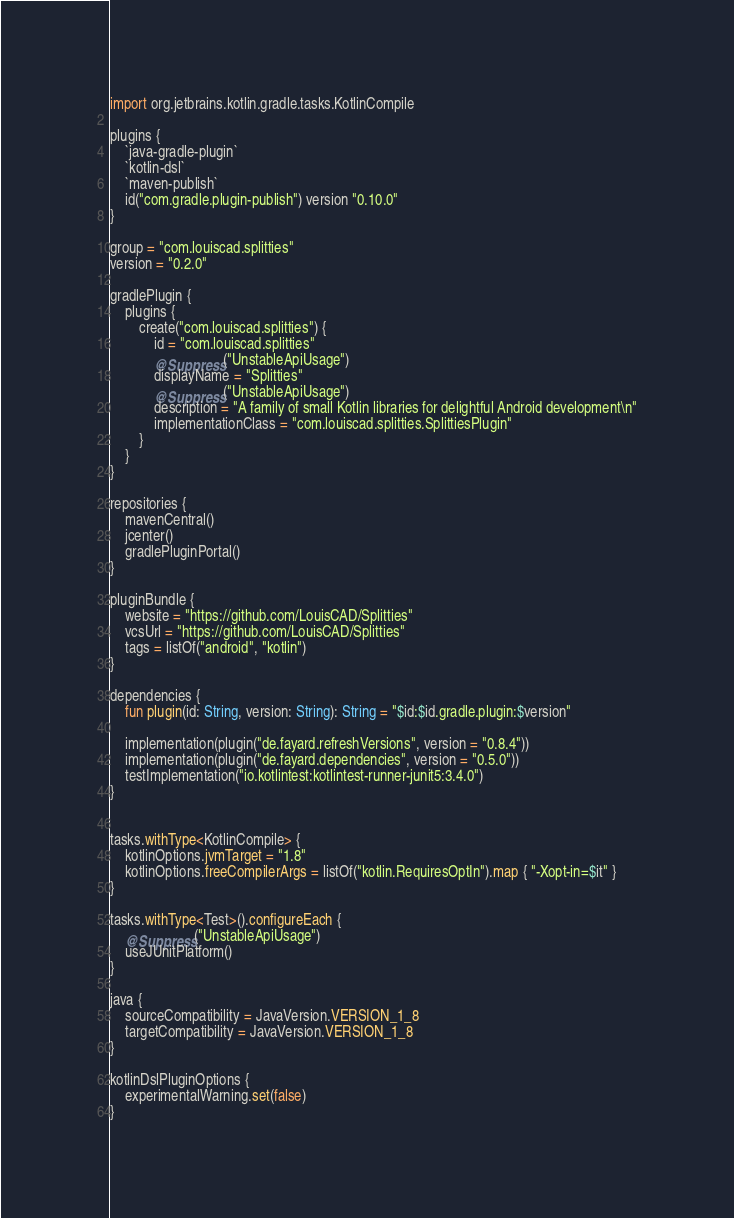<code> <loc_0><loc_0><loc_500><loc_500><_Kotlin_>import org.jetbrains.kotlin.gradle.tasks.KotlinCompile

plugins {
    `java-gradle-plugin`
    `kotlin-dsl`
    `maven-publish`
    id("com.gradle.plugin-publish") version "0.10.0"
}

group = "com.louiscad.splitties"
version = "0.2.0"

gradlePlugin {
    plugins {
        create("com.louiscad.splitties") {
            id = "com.louiscad.splitties"
            @Suppress("UnstableApiUsage")
            displayName = "Splitties"
            @Suppress("UnstableApiUsage")
            description = "A family of small Kotlin libraries for delightful Android development\n"
            implementationClass = "com.louiscad.splitties.SplittiesPlugin"
        }
    }
}

repositories {
    mavenCentral()
    jcenter()
    gradlePluginPortal()
}

pluginBundle {
    website = "https://github.com/LouisCAD/Splitties"
    vcsUrl = "https://github.com/LouisCAD/Splitties"
    tags = listOf("android", "kotlin")
}

dependencies {
    fun plugin(id: String, version: String): String = "$id:$id.gradle.plugin:$version"

    implementation(plugin("de.fayard.refreshVersions", version = "0.8.4"))
    implementation(plugin("de.fayard.dependencies", version = "0.5.0"))
    testImplementation("io.kotlintest:kotlintest-runner-junit5:3.4.0")
}


tasks.withType<KotlinCompile> {
    kotlinOptions.jvmTarget = "1.8"
    kotlinOptions.freeCompilerArgs = listOf("kotlin.RequiresOptIn").map { "-Xopt-in=$it" }
}

tasks.withType<Test>().configureEach {
    @Suppress("UnstableApiUsage")
    useJUnitPlatform()
}

java {
    sourceCompatibility = JavaVersion.VERSION_1_8
    targetCompatibility = JavaVersion.VERSION_1_8
}

kotlinDslPluginOptions {
    experimentalWarning.set(false)
}
</code> 